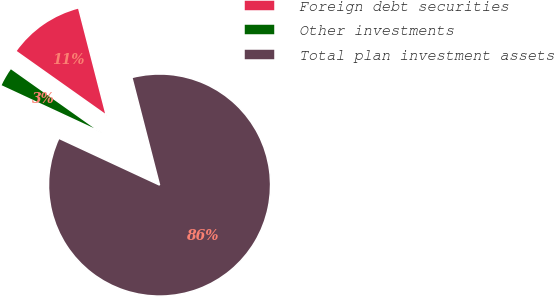<chart> <loc_0><loc_0><loc_500><loc_500><pie_chart><fcel>Foreign debt securities<fcel>Other investments<fcel>Total plan investment assets<nl><fcel>11.18%<fcel>2.88%<fcel>85.94%<nl></chart> 